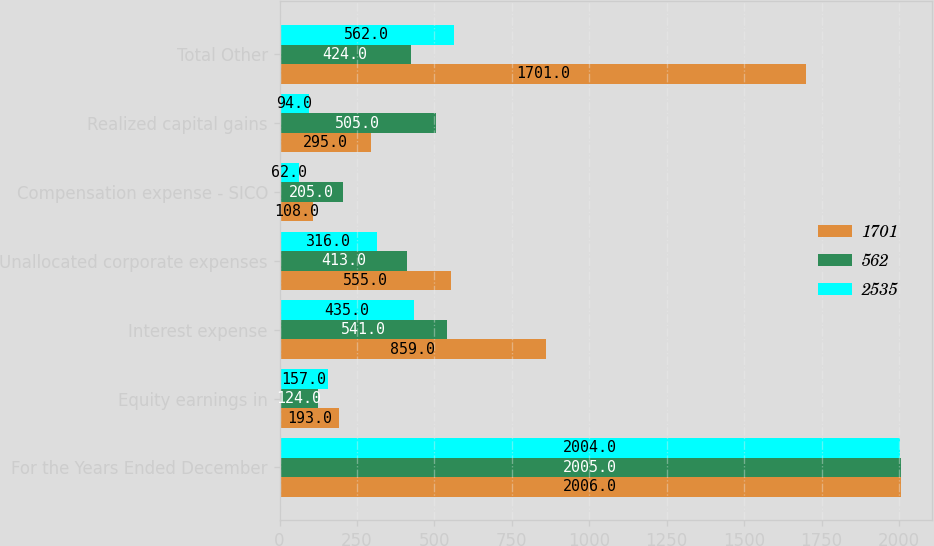Convert chart. <chart><loc_0><loc_0><loc_500><loc_500><stacked_bar_chart><ecel><fcel>For the Years Ended December<fcel>Equity earnings in<fcel>Interest expense<fcel>Unallocated corporate expenses<fcel>Compensation expense - SICO<fcel>Realized capital gains<fcel>Total Other<nl><fcel>1701<fcel>2006<fcel>193<fcel>859<fcel>555<fcel>108<fcel>295<fcel>1701<nl><fcel>562<fcel>2005<fcel>124<fcel>541<fcel>413<fcel>205<fcel>505<fcel>424<nl><fcel>2535<fcel>2004<fcel>157<fcel>435<fcel>316<fcel>62<fcel>94<fcel>562<nl></chart> 